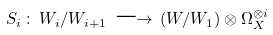Convert formula to latex. <formula><loc_0><loc_0><loc_500><loc_500>S _ { i } \, \colon \, W _ { i } / W _ { i + 1 } \, \longrightarrow \, ( W / W _ { 1 } ) \otimes \Omega ^ { \otimes i } _ { X }</formula> 